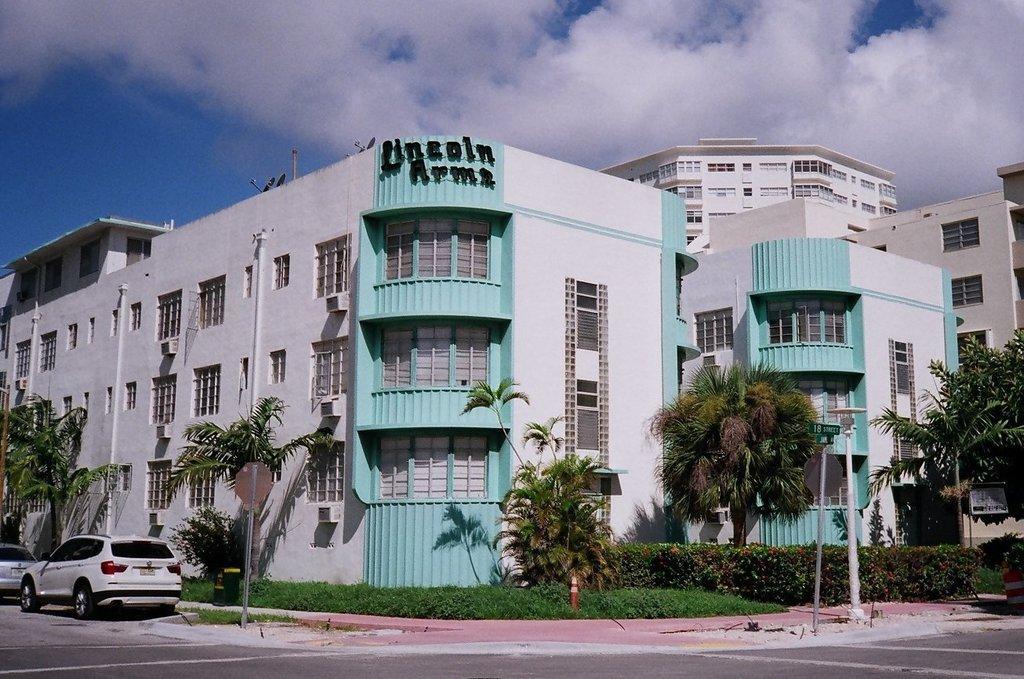Could you give a brief overview of what you see in this image? In this image we can see trees, plants, poles, vehicles on the left side, buildings, windows and clouds in the sky. 